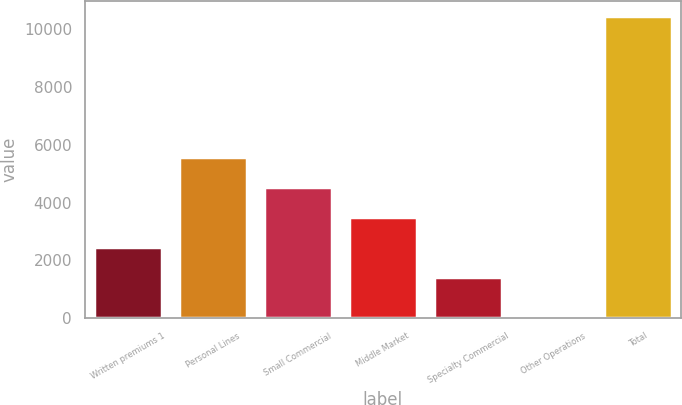<chart> <loc_0><loc_0><loc_500><loc_500><bar_chart><fcel>Written premiums 1<fcel>Personal Lines<fcel>Small Commercial<fcel>Middle Market<fcel>Specialty Commercial<fcel>Other Operations<fcel>Total<nl><fcel>2458.5<fcel>5589<fcel>4545.5<fcel>3502<fcel>1415<fcel>5<fcel>10440<nl></chart> 